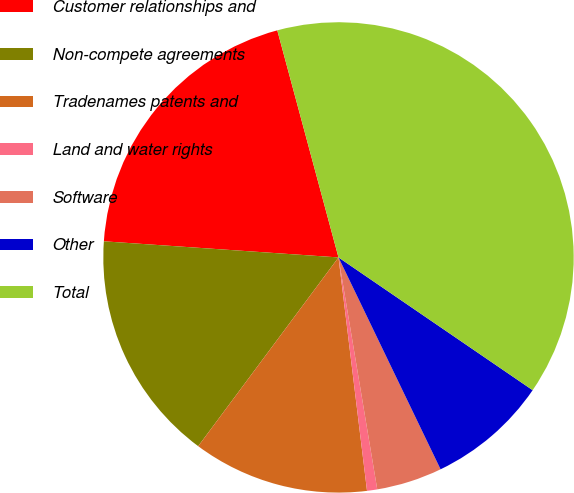Convert chart to OTSL. <chart><loc_0><loc_0><loc_500><loc_500><pie_chart><fcel>Customer relationships and<fcel>Non-compete agreements<fcel>Tradenames patents and<fcel>Land and water rights<fcel>Software<fcel>Other<fcel>Total<nl><fcel>19.72%<fcel>15.92%<fcel>12.11%<fcel>0.7%<fcel>4.51%<fcel>8.31%<fcel>38.74%<nl></chart> 